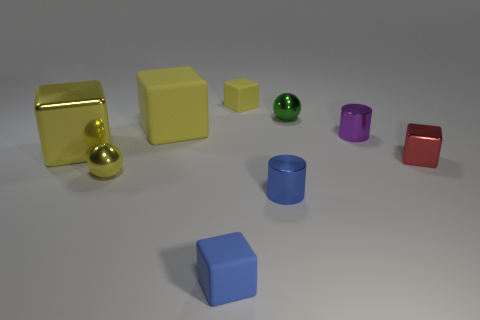Subtract all blue cylinders. How many yellow cubes are left? 3 Subtract all small metallic blocks. How many blocks are left? 4 Subtract 1 blocks. How many blocks are left? 4 Subtract all blue blocks. How many blocks are left? 4 Subtract all cyan cubes. Subtract all yellow balls. How many cubes are left? 5 Subtract all cylinders. How many objects are left? 7 Add 6 tiny purple objects. How many tiny purple objects exist? 7 Subtract 0 yellow cylinders. How many objects are left? 9 Subtract all tiny green metal balls. Subtract all red metal cubes. How many objects are left? 7 Add 5 blue things. How many blue things are left? 7 